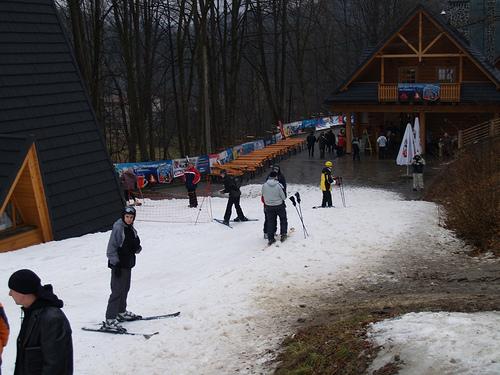Is this a recent photo of a ski resort?
Quick response, please. Yes. What are these people wearing on their feet?
Be succinct. Skis. Are the trees in the photo covered in snow?
Write a very short answer. No. Are they snow skiing?
Short answer required. Yes. Is the snow dirty?
Keep it brief. Yes. 